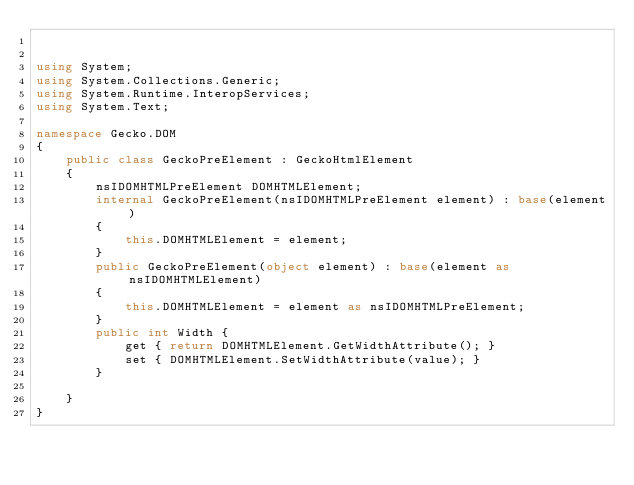<code> <loc_0><loc_0><loc_500><loc_500><_C#_>

using System;
using System.Collections.Generic;
using System.Runtime.InteropServices;
using System.Text;

namespace Gecko.DOM
{	
	public class GeckoPreElement : GeckoHtmlElement
	{
		nsIDOMHTMLPreElement DOMHTMLElement;
		internal GeckoPreElement(nsIDOMHTMLPreElement element) : base(element)
		{
			this.DOMHTMLElement = element;
		}
		public GeckoPreElement(object element) : base(element as nsIDOMHTMLElement)
		{
			this.DOMHTMLElement = element as nsIDOMHTMLPreElement;
		}
		public int Width {
			get { return DOMHTMLElement.GetWidthAttribute(); }
			set { DOMHTMLElement.SetWidthAttribute(value); }
		}

	}
}

</code> 